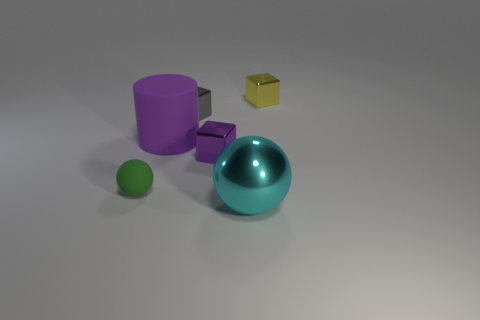Subtract 1 blocks. How many blocks are left? 2 Add 1 red shiny objects. How many objects exist? 7 Subtract all cylinders. How many objects are left? 5 Subtract 1 cyan balls. How many objects are left? 5 Subtract all tiny metallic blocks. Subtract all gray cubes. How many objects are left? 2 Add 2 gray shiny cubes. How many gray shiny cubes are left? 3 Add 2 tiny green metallic blocks. How many tiny green metallic blocks exist? 2 